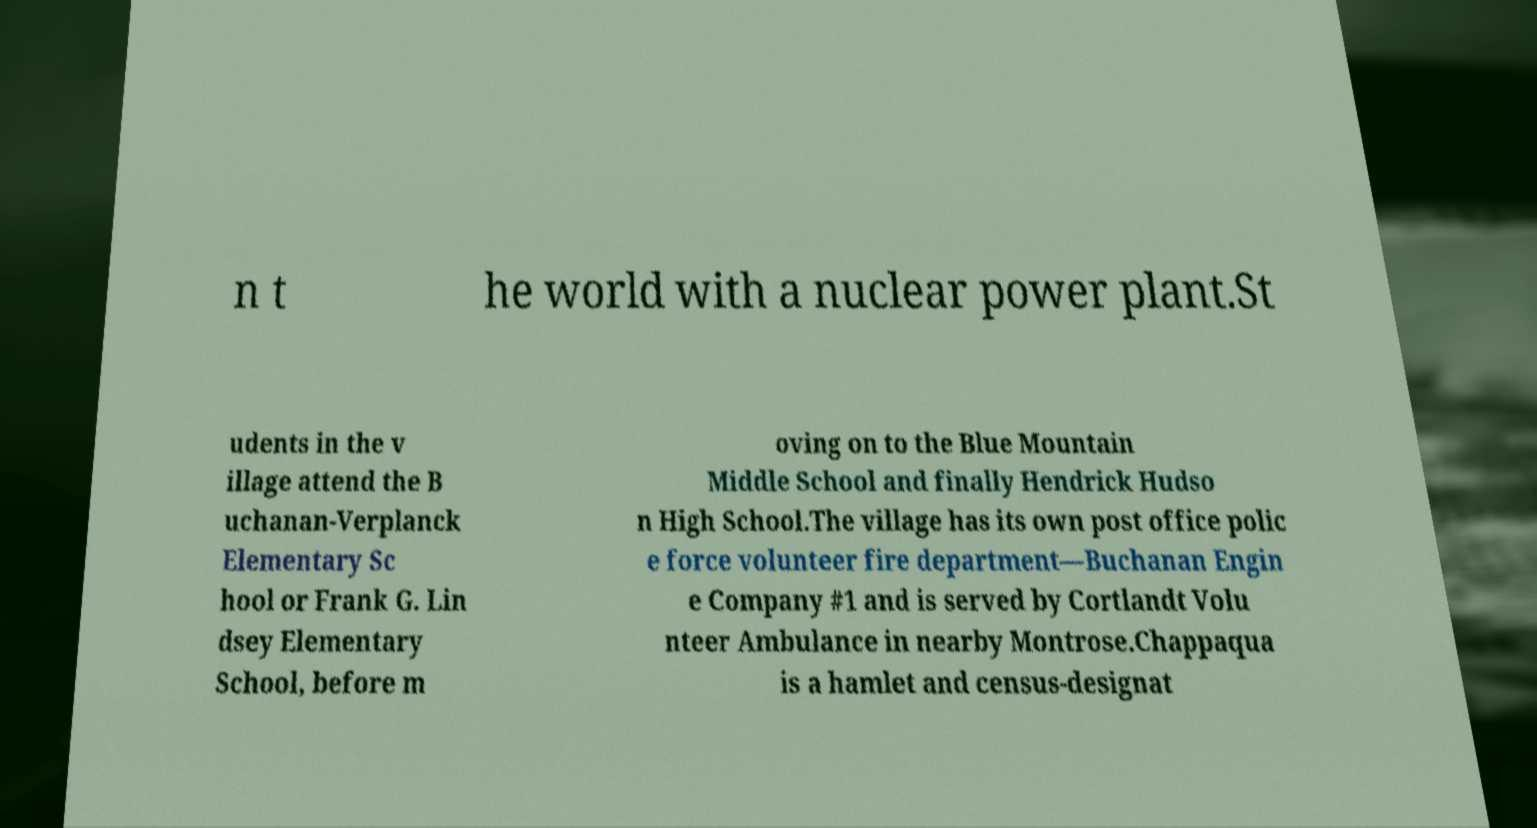Can you read and provide the text displayed in the image?This photo seems to have some interesting text. Can you extract and type it out for me? n t he world with a nuclear power plant.St udents in the v illage attend the B uchanan-Verplanck Elementary Sc hool or Frank G. Lin dsey Elementary School, before m oving on to the Blue Mountain Middle School and finally Hendrick Hudso n High School.The village has its own post office polic e force volunteer fire department—Buchanan Engin e Company #1 and is served by Cortlandt Volu nteer Ambulance in nearby Montrose.Chappaqua is a hamlet and census-designat 